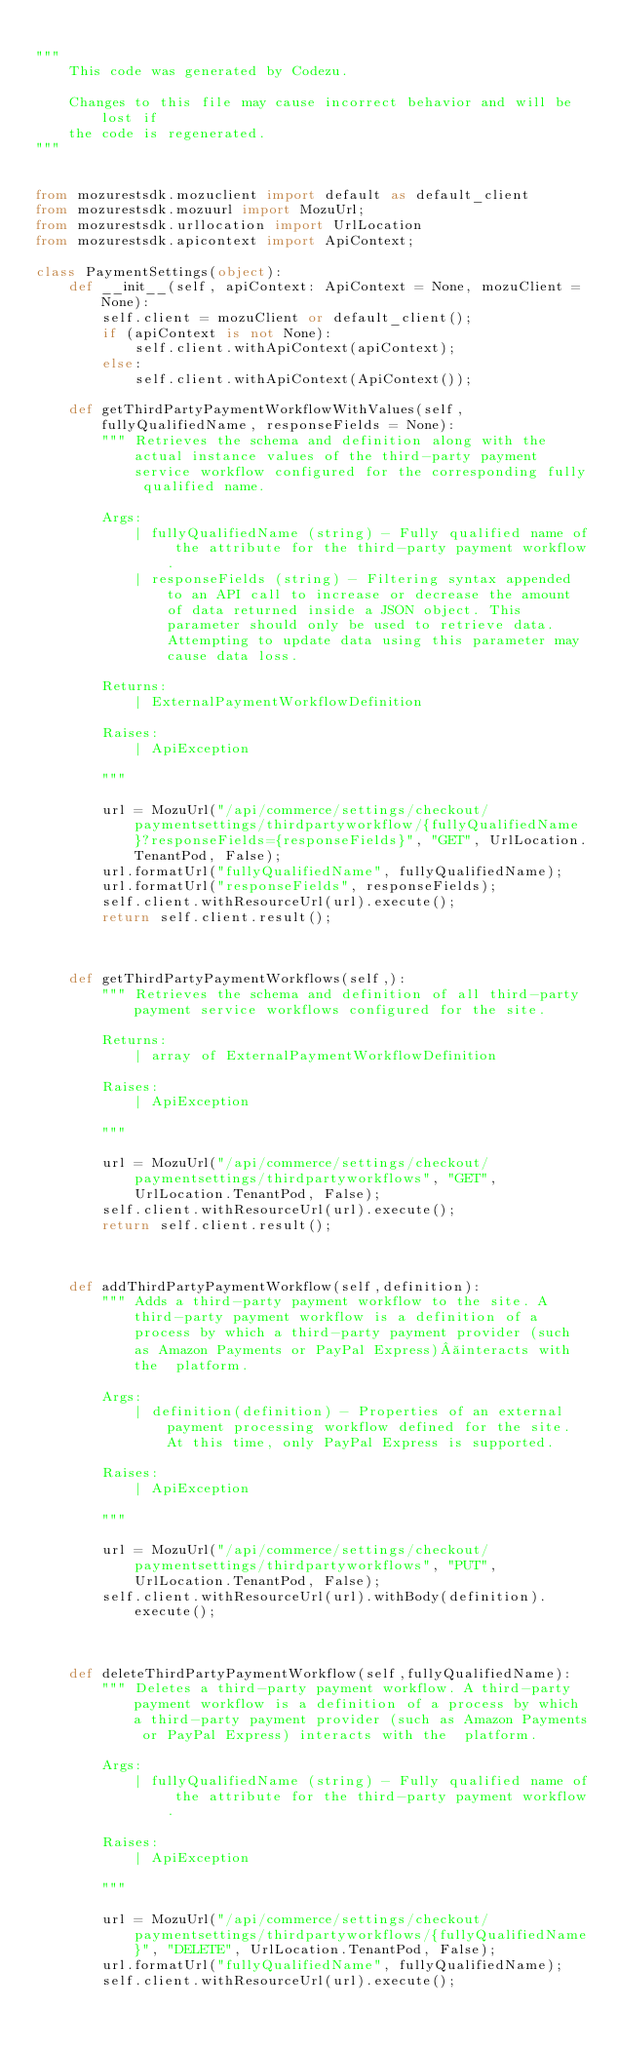Convert code to text. <code><loc_0><loc_0><loc_500><loc_500><_Python_>
"""
    This code was generated by Codezu.     

    Changes to this file may cause incorrect behavior and will be lost if
    the code is regenerated.
"""


from mozurestsdk.mozuclient import default as default_client
from mozurestsdk.mozuurl import MozuUrl;
from mozurestsdk.urllocation import UrlLocation
from mozurestsdk.apicontext import ApiContext;

class PaymentSettings(object):
	def __init__(self, apiContext: ApiContext = None, mozuClient = None):
		self.client = mozuClient or default_client();
		if (apiContext is not None):
			self.client.withApiContext(apiContext);
		else:
			self.client.withApiContext(ApiContext());
	
	def getThirdPartyPaymentWorkflowWithValues(self,fullyQualifiedName, responseFields = None):
		""" Retrieves the schema and definition along with the actual instance values of the third-party payment service workflow configured for the corresponding fully qualified name.
		
		Args:
			| fullyQualifiedName (string) - Fully qualified name of the attribute for the third-party payment workflow.
			| responseFields (string) - Filtering syntax appended to an API call to increase or decrease the amount of data returned inside a JSON object. This parameter should only be used to retrieve data. Attempting to update data using this parameter may cause data loss.
		
		Returns:
			| ExternalPaymentWorkflowDefinition 
		
		Raises:
			| ApiException
		
		"""

		url = MozuUrl("/api/commerce/settings/checkout/paymentsettings/thirdpartyworkflow/{fullyQualifiedName}?responseFields={responseFields}", "GET", UrlLocation.TenantPod, False);
		url.formatUrl("fullyQualifiedName", fullyQualifiedName);
		url.formatUrl("responseFields", responseFields);
		self.client.withResourceUrl(url).execute();
		return self.client.result();

	
		
	def getThirdPartyPaymentWorkflows(self,):
		""" Retrieves the schema and definition of all third-party payment service workflows configured for the site.
		
		Returns:
			| array of ExternalPaymentWorkflowDefinition 
		
		Raises:
			| ApiException
		
		"""

		url = MozuUrl("/api/commerce/settings/checkout/paymentsettings/thirdpartyworkflows", "GET", UrlLocation.TenantPod, False);
		self.client.withResourceUrl(url).execute();
		return self.client.result();

	
		
	def addThirdPartyPaymentWorkflow(self,definition):
		""" Adds a third-party payment workflow to the site. A third-party payment workflow is a definition of a process by which a third-party payment provider (such as Amazon Payments or PayPal Express) interacts with the  platform.
		
		Args:
			| definition(definition) - Properties of an external payment processing workflow defined for the site. At this time, only PayPal Express is supported.
		
		Raises:
			| ApiException
		
		"""

		url = MozuUrl("/api/commerce/settings/checkout/paymentsettings/thirdpartyworkflows", "PUT", UrlLocation.TenantPod, False);
		self.client.withResourceUrl(url).withBody(definition).execute();

	
		
	def deleteThirdPartyPaymentWorkflow(self,fullyQualifiedName):
		""" Deletes a third-party payment workflow. A third-party payment workflow is a definition of a process by which a third-party payment provider (such as Amazon Payments or PayPal Express) interacts with the  platform. 
		
		Args:
			| fullyQualifiedName (string) - Fully qualified name of the attribute for the third-party payment workflow.
		
		Raises:
			| ApiException
		
		"""

		url = MozuUrl("/api/commerce/settings/checkout/paymentsettings/thirdpartyworkflows/{fullyQualifiedName}", "DELETE", UrlLocation.TenantPod, False);
		url.formatUrl("fullyQualifiedName", fullyQualifiedName);
		self.client.withResourceUrl(url).execute();

	
	
	</code> 